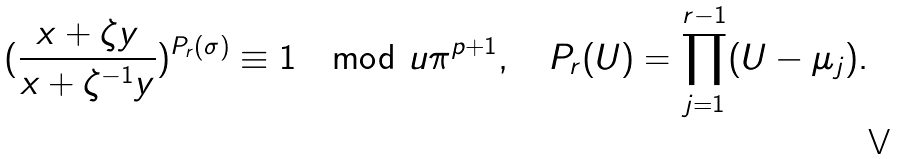Convert formula to latex. <formula><loc_0><loc_0><loc_500><loc_500>( \frac { x + \zeta y } { x + \zeta ^ { - 1 } y } ) ^ { P _ { r } ( \sigma ) } \equiv 1 \mod u \pi ^ { p + 1 } , \quad P _ { r } ( U ) = \prod _ { j = 1 } ^ { r - 1 } ( U - \mu _ { j } ) .</formula> 